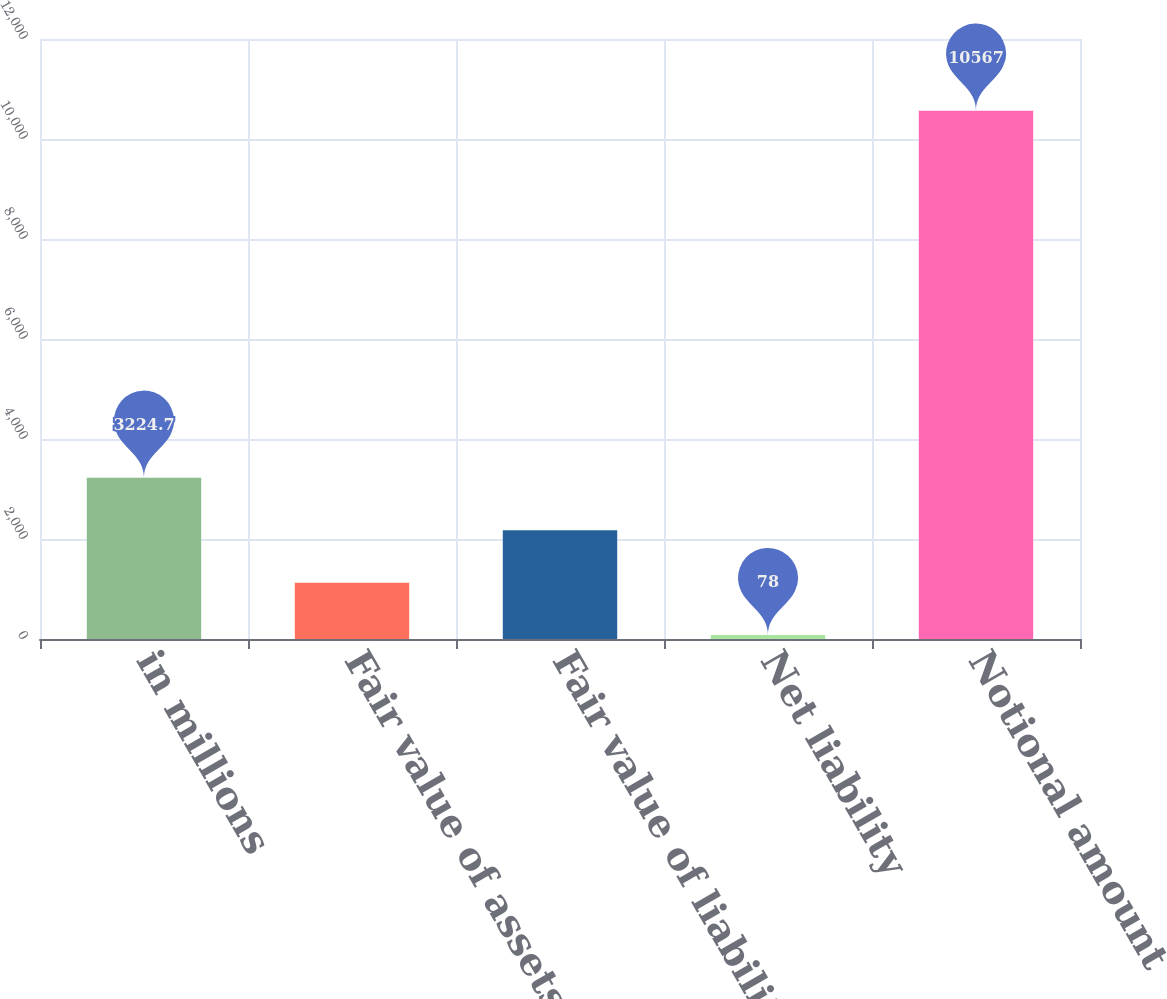Convert chart. <chart><loc_0><loc_0><loc_500><loc_500><bar_chart><fcel>in millions<fcel>Fair value of assets<fcel>Fair value of liabilities<fcel>Net liability<fcel>Notional amount<nl><fcel>3224.7<fcel>1126.9<fcel>2175.8<fcel>78<fcel>10567<nl></chart> 